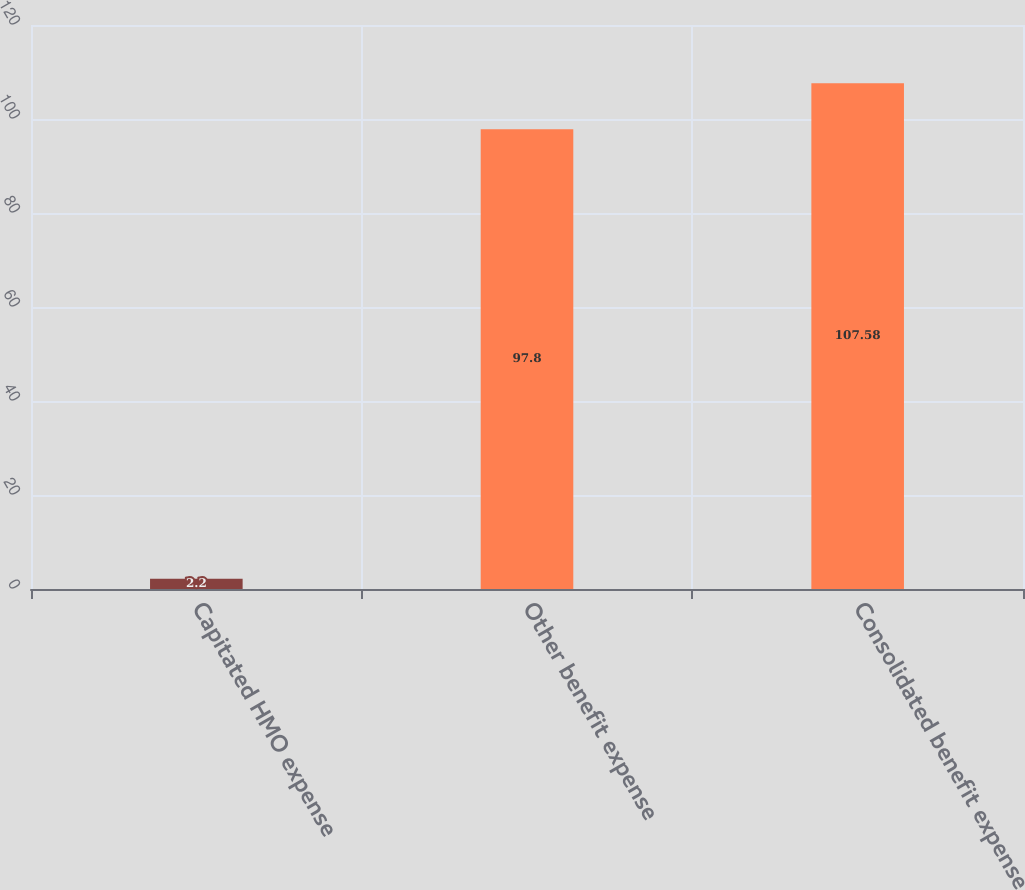Convert chart to OTSL. <chart><loc_0><loc_0><loc_500><loc_500><bar_chart><fcel>Capitated HMO expense<fcel>Other benefit expense<fcel>Consolidated benefit expense<nl><fcel>2.2<fcel>97.8<fcel>107.58<nl></chart> 